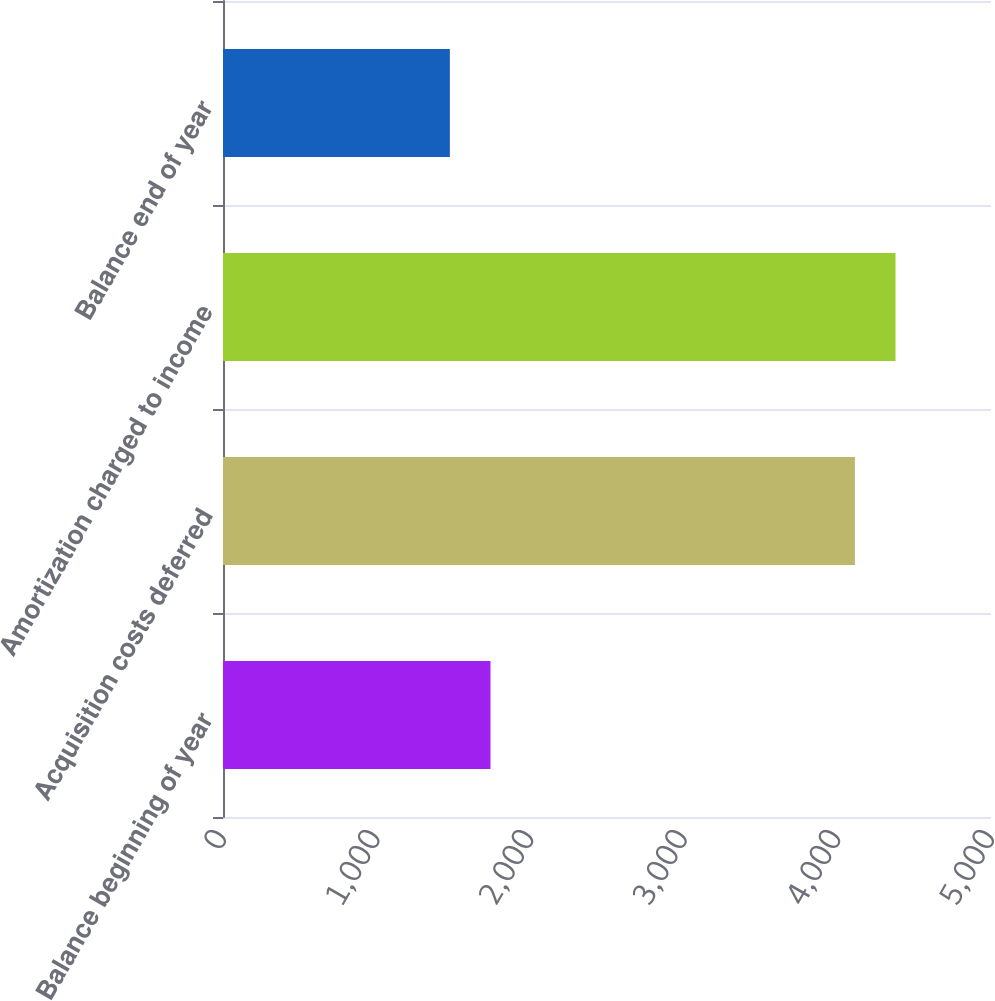Convert chart. <chart><loc_0><loc_0><loc_500><loc_500><bar_chart><fcel>Balance beginning of year<fcel>Acquisition costs deferred<fcel>Amortization charged to income<fcel>Balance end of year<nl><fcel>1741.4<fcel>4114<fcel>4378.4<fcel>1477<nl></chart> 